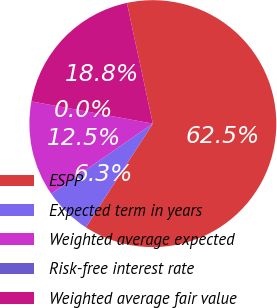Convert chart. <chart><loc_0><loc_0><loc_500><loc_500><pie_chart><fcel>ESPP<fcel>Expected term in years<fcel>Weighted average expected<fcel>Risk-free interest rate<fcel>Weighted average fair value<nl><fcel>62.49%<fcel>6.25%<fcel>12.5%<fcel>0.0%<fcel>18.75%<nl></chart> 